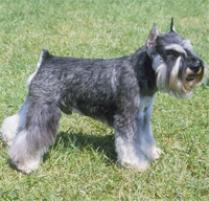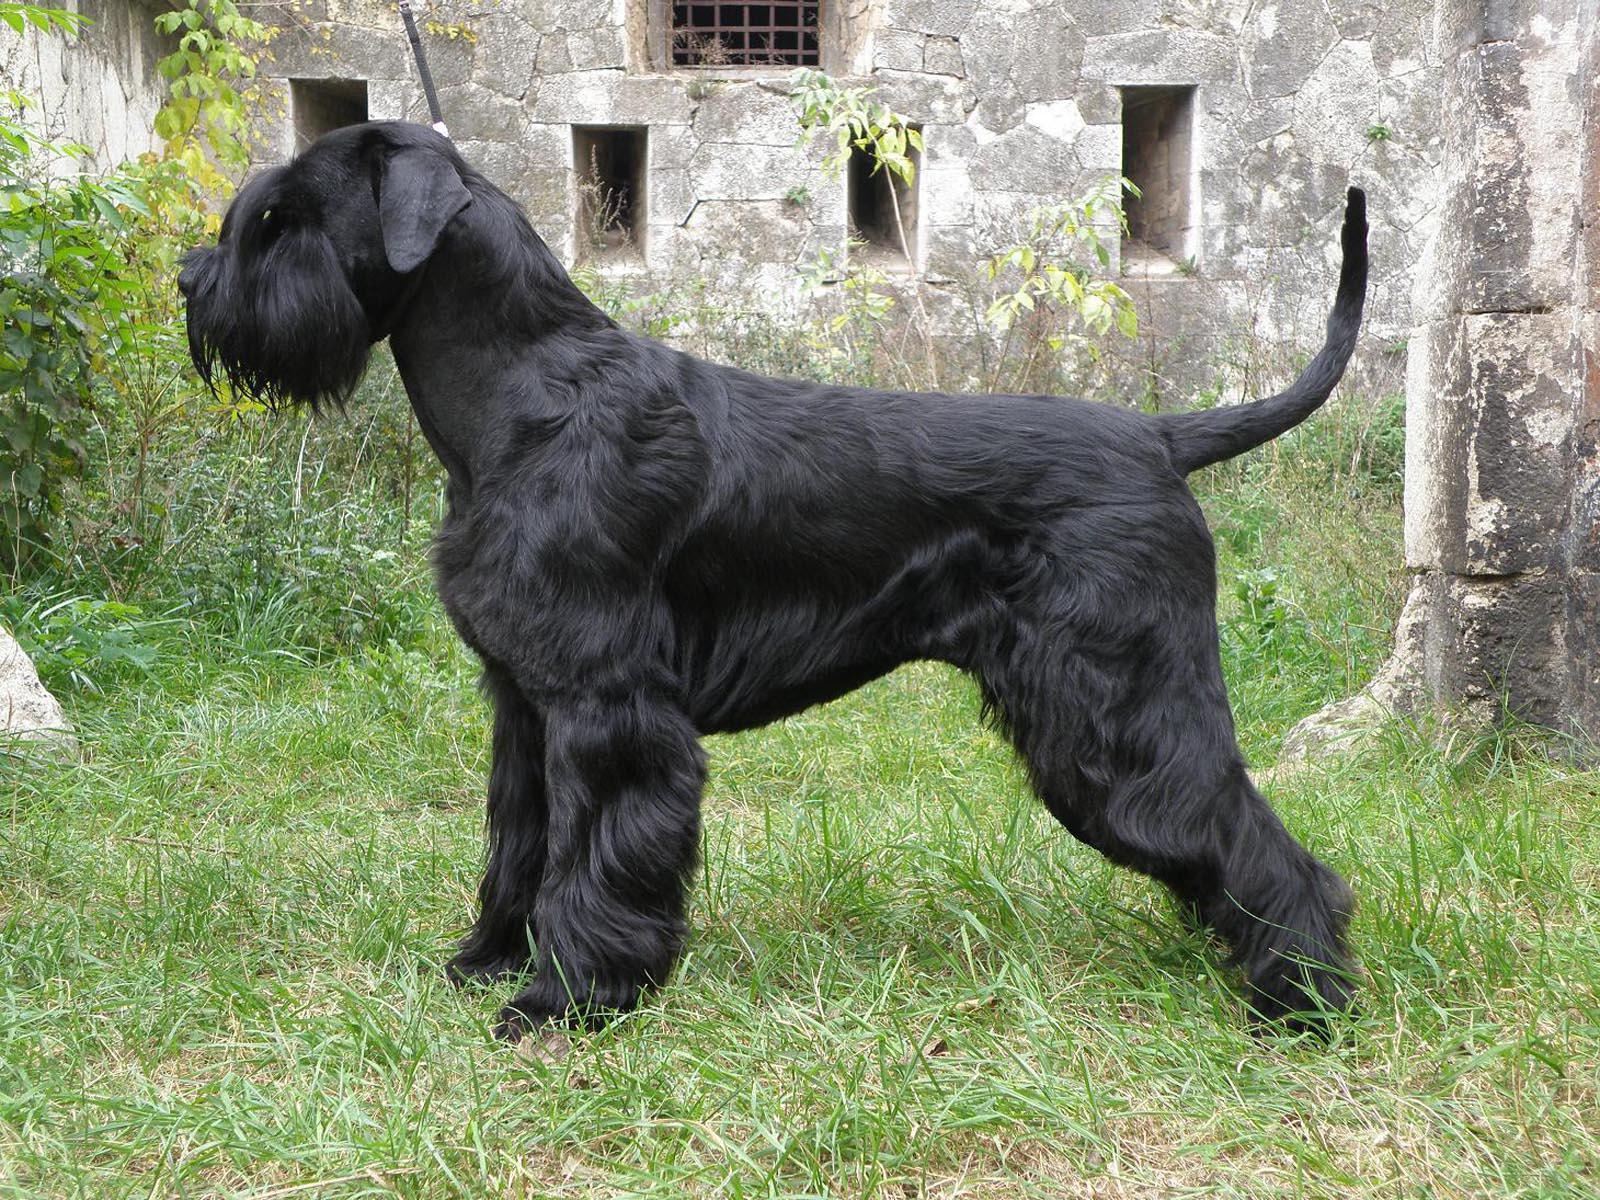The first image is the image on the left, the second image is the image on the right. Given the left and right images, does the statement "A dog is standing in front of a stone wall." hold true? Answer yes or no. Yes. The first image is the image on the left, the second image is the image on the right. Given the left and right images, does the statement "Right image shows a dog standing outdoors in profile, with body turned leftward." hold true? Answer yes or no. Yes. 